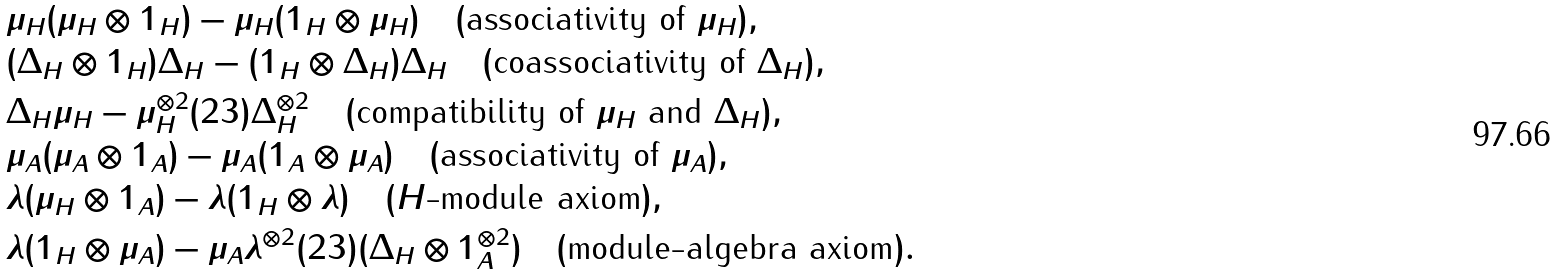<formula> <loc_0><loc_0><loc_500><loc_500>& \mu _ { H } ( \mu _ { H } \otimes 1 _ { H } ) - \mu _ { H } ( 1 _ { H } \otimes \mu _ { H } ) \quad ( \text {associativity of } \mu _ { H } ) , \\ & ( \Delta _ { H } \otimes 1 _ { H } ) \Delta _ { H } - ( 1 _ { H } \otimes \Delta _ { H } ) \Delta _ { H } \quad ( \text {coassociativity of } \Delta _ { H } ) , \\ & \Delta _ { H } \mu _ { H } - \mu _ { H } ^ { \otimes 2 } ( 2 3 ) \Delta _ { H } ^ { \otimes 2 } \quad ( \text {compatibility of } \mu _ { H } \text { and } \Delta _ { H } ) , \\ & \mu _ { A } ( \mu _ { A } \otimes 1 _ { A } ) - \mu _ { A } ( 1 _ { A } \otimes \mu _ { A } ) \quad ( \text {associativity of } \mu _ { A } ) , \\ & \lambda ( \mu _ { H } \otimes 1 _ { A } ) - \lambda ( 1 _ { H } \otimes \lambda ) \quad ( H \text {-module axiom} ) , \\ & \lambda ( 1 _ { H } \otimes \mu _ { A } ) - \mu _ { A } \lambda ^ { \otimes 2 } ( 2 3 ) ( \Delta _ { H } \otimes 1 _ { A } ^ { \otimes 2 } ) \quad ( \text {module-algebra axiom} ) .</formula> 